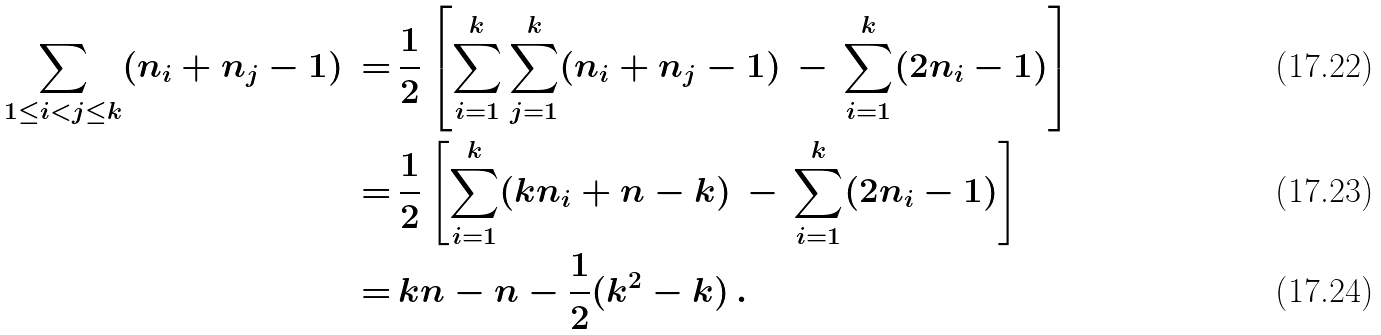Convert formula to latex. <formula><loc_0><loc_0><loc_500><loc_500>\sum _ { 1 \leq i < j \leq k } ( n _ { i } + n _ { j } - 1 ) \, = & \, \frac { 1 } { 2 } \left [ \sum _ { i = 1 } ^ { k } \sum _ { j = 1 } ^ { k } ( n _ { i } + n _ { j } - 1 ) \, - \, \sum _ { i = 1 } ^ { k } ( 2 n _ { i } - 1 ) \right ] \\ = & \, \frac { 1 } { 2 } \left [ \sum _ { i = 1 } ^ { k } ( k n _ { i } + n - k ) \, - \, \sum _ { i = 1 } ^ { k } ( 2 n _ { i } - 1 ) \right ] \\ = & \, k n - n - \frac { 1 } { 2 } ( k ^ { 2 } - k ) \, .</formula> 